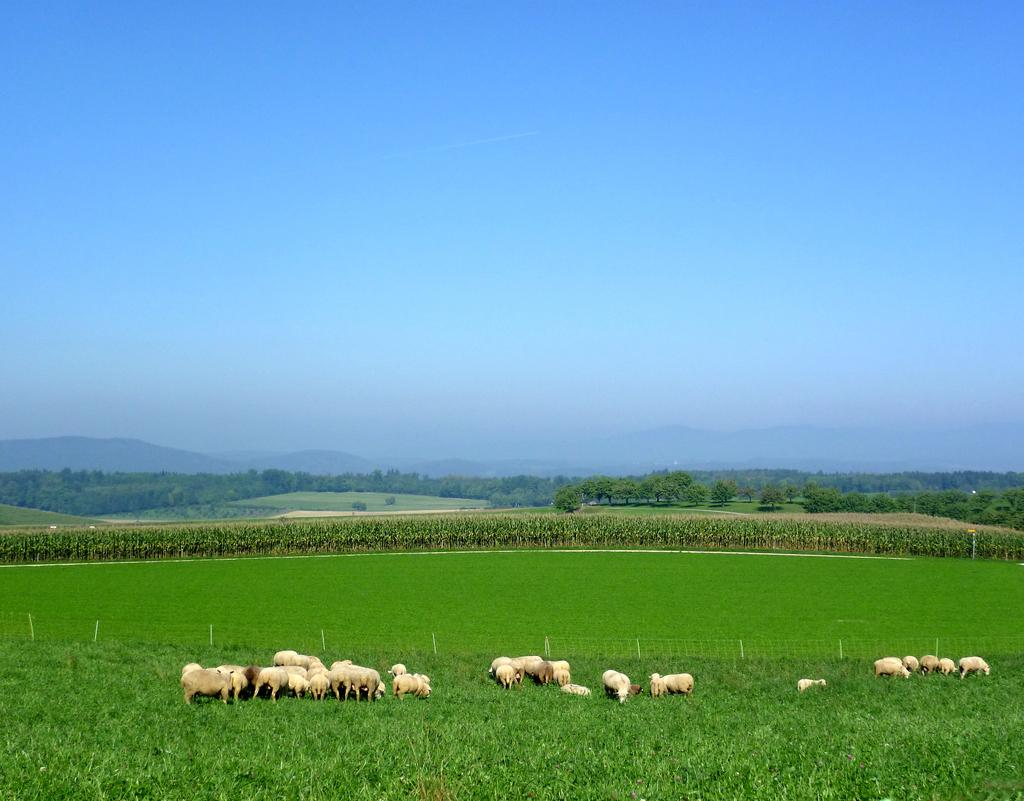What type of vegetation is at the bottom of the image? There is grass at the bottom of the image. What other living creatures can be seen in the image? There are animals visible in the image. What can be seen in the middle of the image? There are trees and hills in the middle of the image. What is visible at the top of the image? The sky is visible at the top of the image. Can you tell me which animal has the most distinct eye markings in the image? There is no specific animal mentioned in the image, and therefore no eye markings can be observed or compared. What type of fight is taking place between the animals in the image? There is no fight or conflict depicted among the animals in the image. 